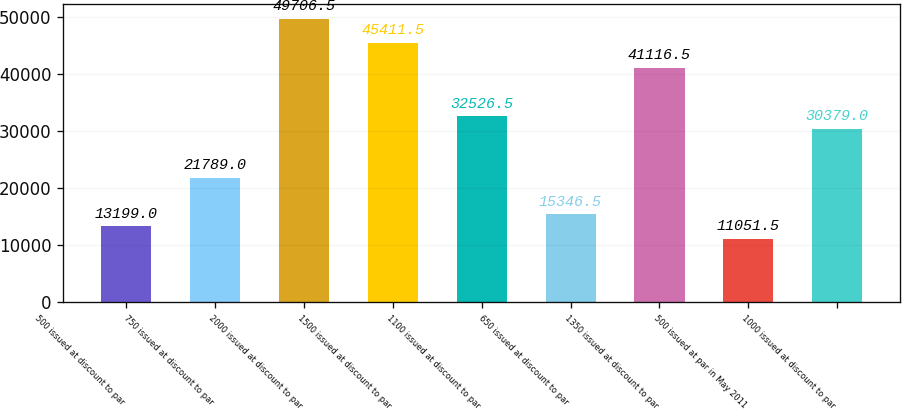Convert chart to OTSL. <chart><loc_0><loc_0><loc_500><loc_500><bar_chart><fcel>500 issued at discount to par<fcel>750 issued at discount to par<fcel>2000 issued at discount to par<fcel>1500 issued at discount to par<fcel>1100 issued at discount to par<fcel>650 issued at discount to par<fcel>1350 issued at discount to par<fcel>500 issued at par in May 2011<fcel>1000 issued at discount to par<nl><fcel>13199<fcel>21789<fcel>49706.5<fcel>45411.5<fcel>32526.5<fcel>15346.5<fcel>41116.5<fcel>11051.5<fcel>30379<nl></chart> 